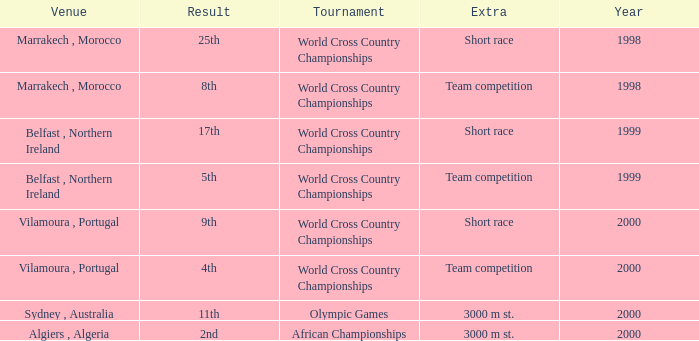Tell me the venue for extra of short race and year less than 1999 Marrakech , Morocco. I'm looking to parse the entire table for insights. Could you assist me with that? {'header': ['Venue', 'Result', 'Tournament', 'Extra', 'Year'], 'rows': [['Marrakech , Morocco', '25th', 'World Cross Country Championships', 'Short race', '1998'], ['Marrakech , Morocco', '8th', 'World Cross Country Championships', 'Team competition', '1998'], ['Belfast , Northern Ireland', '17th', 'World Cross Country Championships', 'Short race', '1999'], ['Belfast , Northern Ireland', '5th', 'World Cross Country Championships', 'Team competition', '1999'], ['Vilamoura , Portugal', '9th', 'World Cross Country Championships', 'Short race', '2000'], ['Vilamoura , Portugal', '4th', 'World Cross Country Championships', 'Team competition', '2000'], ['Sydney , Australia', '11th', 'Olympic Games', '3000 m st.', '2000'], ['Algiers , Algeria', '2nd', 'African Championships', '3000 m st.', '2000']]} 